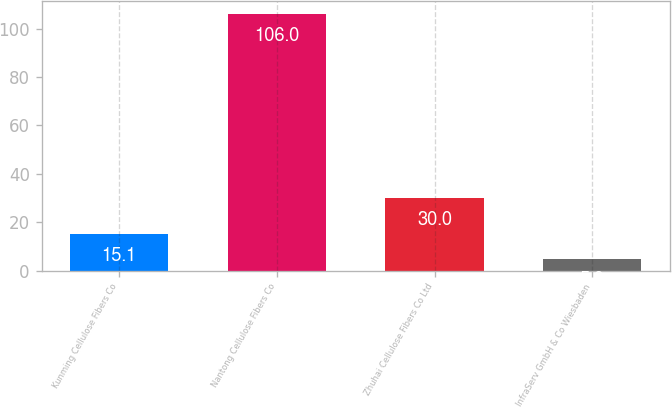<chart> <loc_0><loc_0><loc_500><loc_500><bar_chart><fcel>Kunming Cellulose Fibers Co<fcel>Nantong Cellulose Fibers Co<fcel>Zhuhai Cellulose Fibers Co Ltd<fcel>InfraServ GmbH & Co Wiesbaden<nl><fcel>15.1<fcel>106<fcel>30<fcel>5<nl></chart> 